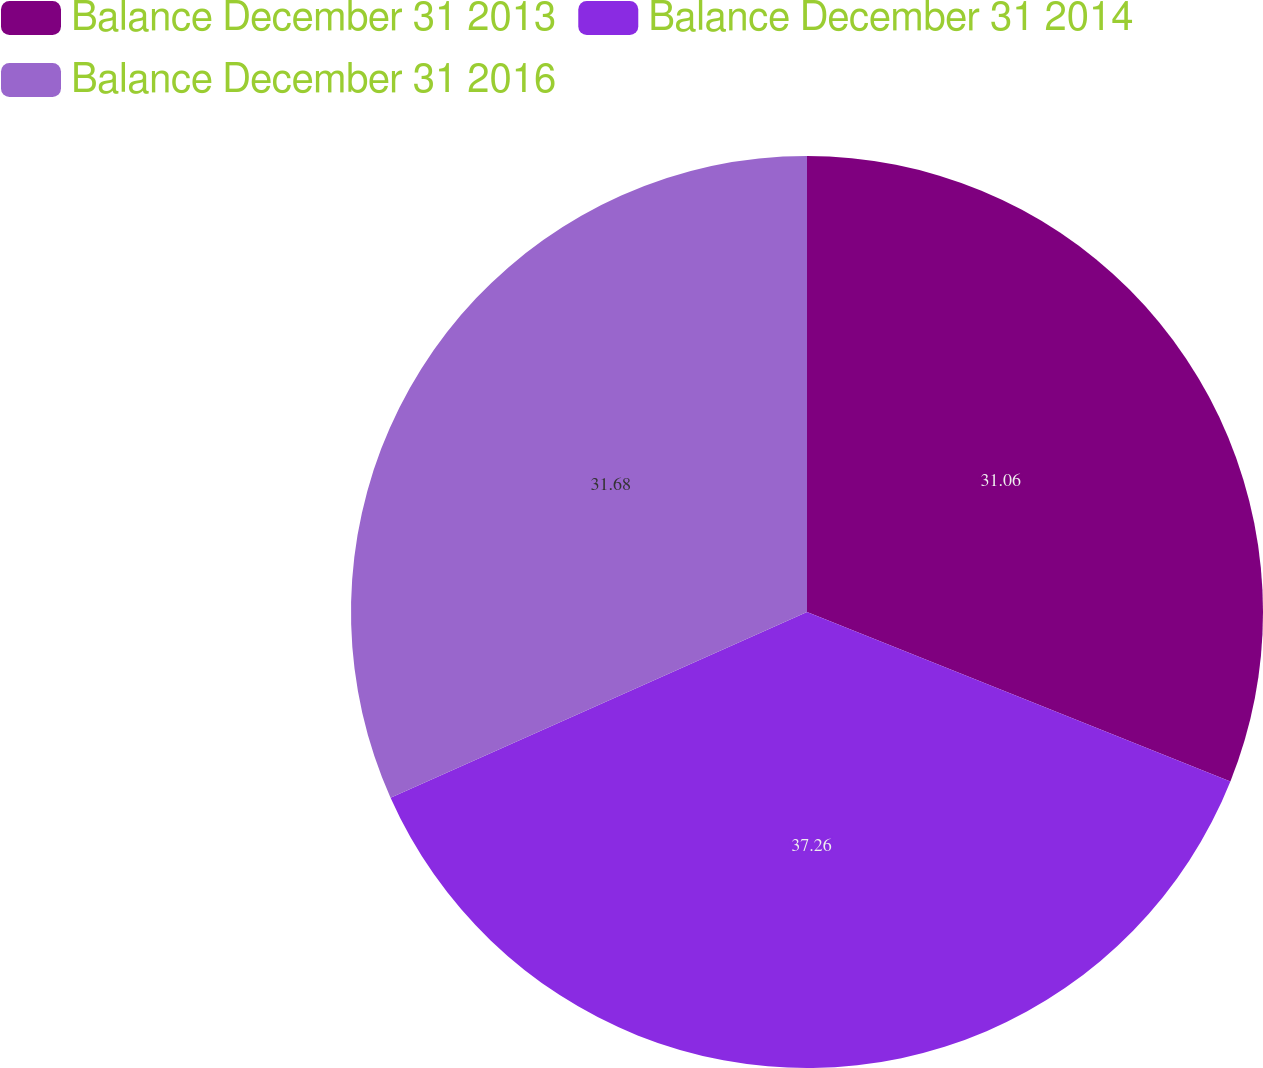Convert chart to OTSL. <chart><loc_0><loc_0><loc_500><loc_500><pie_chart><fcel>Balance December 31 2013<fcel>Balance December 31 2014<fcel>Balance December 31 2016<nl><fcel>31.06%<fcel>37.27%<fcel>31.68%<nl></chart> 